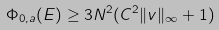Convert formula to latex. <formula><loc_0><loc_0><loc_500><loc_500>\Phi _ { 0 , \L a } ( E ) \geq 3 N ^ { 2 } ( C ^ { 2 } \| v \| _ { \infty } + 1 )</formula> 